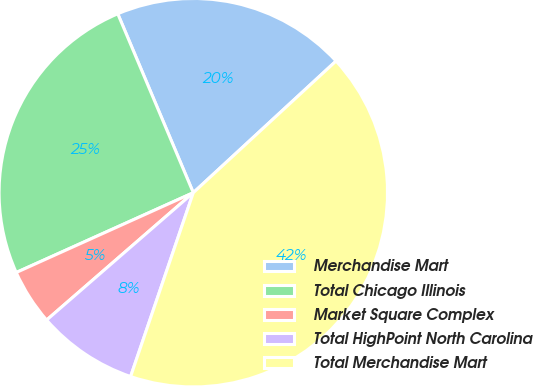<chart> <loc_0><loc_0><loc_500><loc_500><pie_chart><fcel>Merchandise Mart<fcel>Total Chicago Illinois<fcel>Market Square Complex<fcel>Total HighPoint North Carolina<fcel>Total Merchandise Mart<nl><fcel>19.5%<fcel>25.38%<fcel>4.64%<fcel>8.39%<fcel>42.09%<nl></chart> 